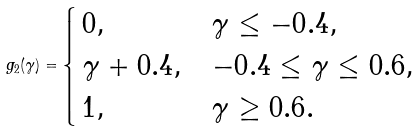Convert formula to latex. <formula><loc_0><loc_0><loc_500><loc_500>g _ { 2 } ( \gamma ) = \begin{cases} \, 0 , & \gamma \leq - 0 . 4 , \\ \, \gamma + 0 . 4 , & - 0 . 4 \leq \gamma \leq 0 . 6 , \\ \, 1 , & \gamma \geq 0 . 6 . \end{cases}</formula> 